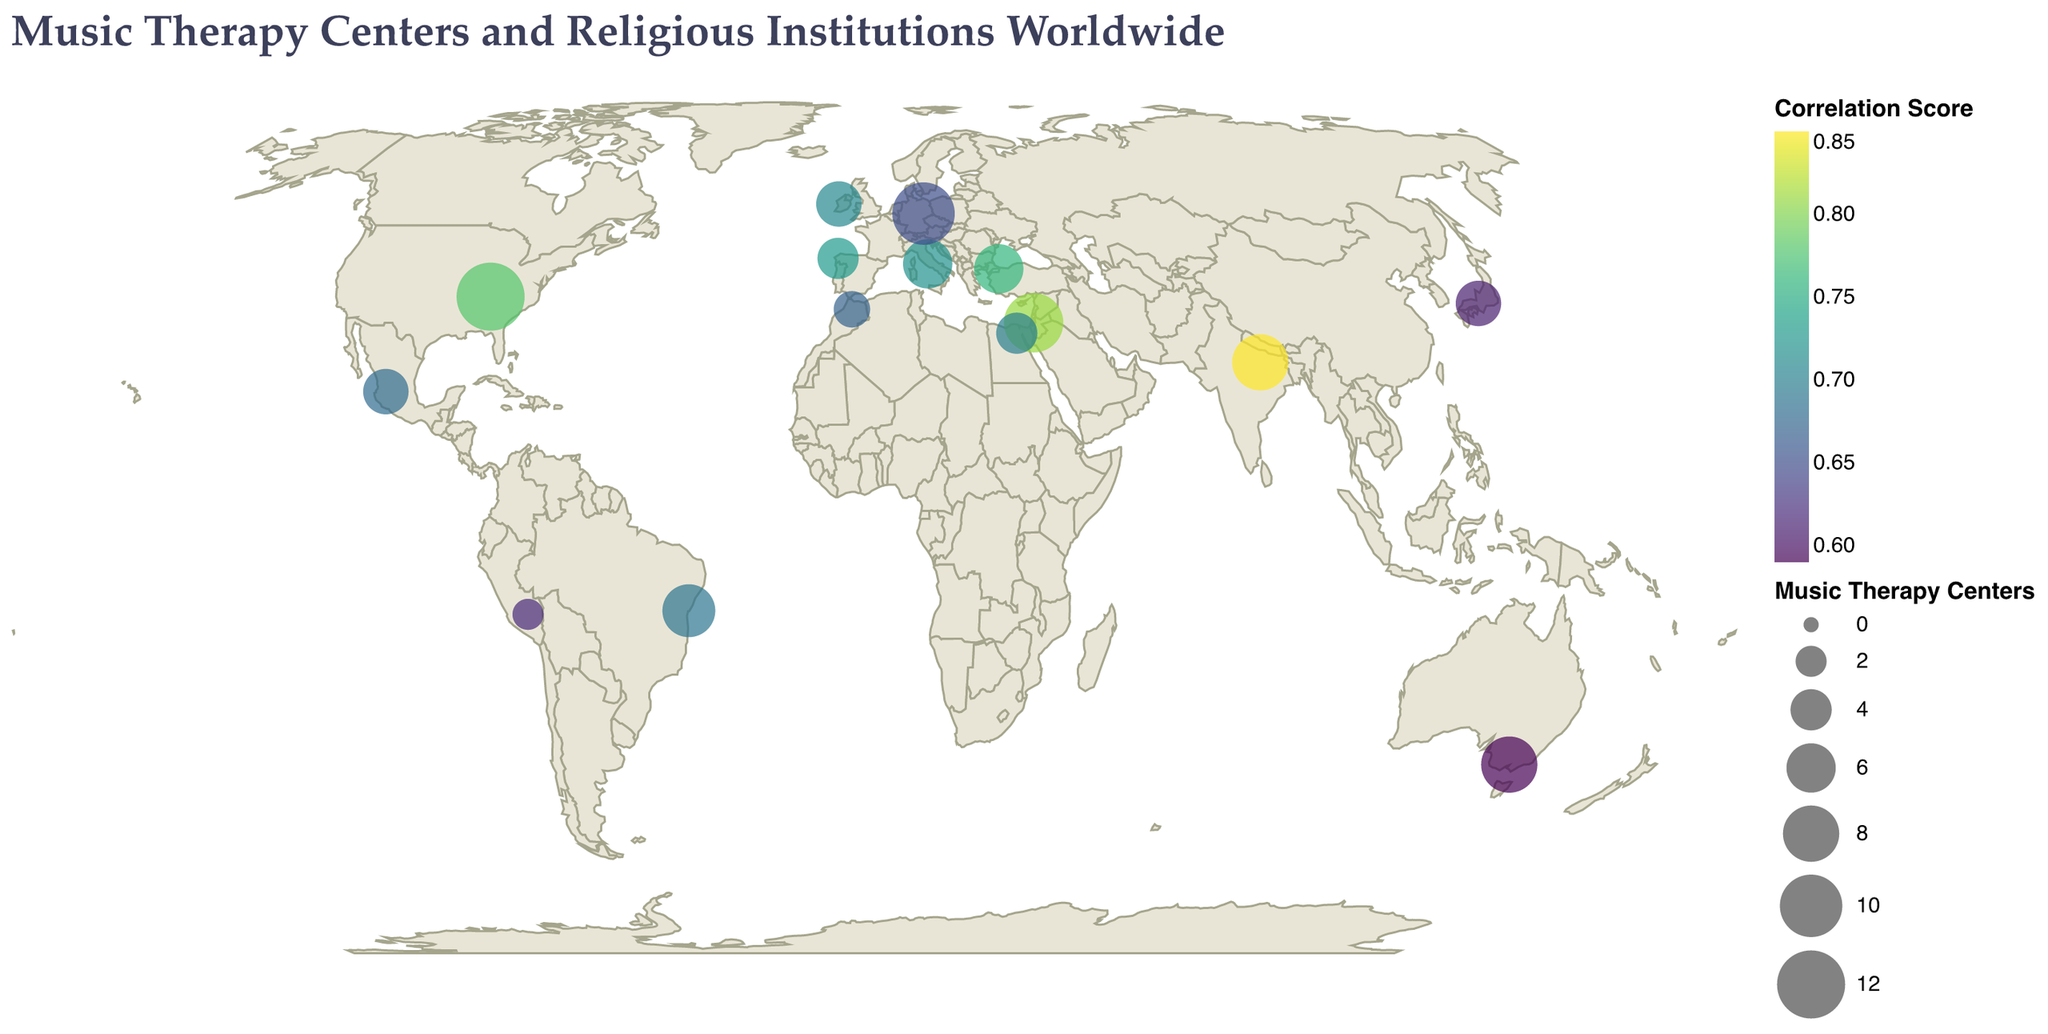How many Music Therapy Centers are there in Nashville? The plot shows the number of Music Therapy Centers indicated by the size of the circle. Nashville has a labeled count of 12 Music Therapy Centers.
Answer: 12 Which city has the highest number of Religious Institutions? The plot colorizes the cities based on the number of Religious Institutions. Jerusalem has the highest number of Religious Institutions, with 128 as indicated in the data table.
Answer: Jerusalem What is the Correlation Score between Music Therapy Centers and Religious Institutions in Galway? The color legend indicates the Correlation Score, and the data table shows that Galway has a Correlation Score of 0.71.
Answer: 0.71 Compare the number of Music Therapy Centers in Rome and Kyoto. Which city has more? According to the data table, Rome has 6 Music Therapy Centers while Kyoto has 5. Thus, Rome has more Music Therapy Centers.
Answer: Rome What are the colors representing in the circles on the plot? The color represents the Correlation Score between Music Therapy Centers and Religious Institutions, with a scale legend showing the range of values.
Answer: Correlation Score Which city has the lowest Correlation Score and what is that value? Melbourne has the lowest Correlation Score, which is 0.59 according to the data table.
Answer: Melbourne, 0.59 What is the total number of Music Therapy Centers in the cities provided? Sum the number of Music Therapy Centers: 12 (Nashville) + 8 (Varanasi) + 6 (Rome) + 5 (Kyoto) + 7 (Salvador) + 9 (Jerusalem) + 10 (Leipzig) + 4 (Santiago de Compostela) + 3 (Fez) + 8 (Melbourne) + 5 (Galway) + 6 (Istanbul) + 2 (Cusco) + 4 (Cairo) + 5 (Guadalajara) = 94.
Answer: 94 Which cities have more than 100 Religious Institutions? Rome (112), Jerusalem (128), and Istanbul (103) have more than 100 Religious Institutions as shown in the data table.
Answer: Rome, Jerusalem, Istanbul Is there a relationship between the number of Religious Institutions and Music Therapy Centers in the plot? The plot shows a positive correlation between the number of Religious Institutions and Music Therapy Centers in most cities, as indicated by the correlation scores. For example, Varanasi has both high numbers and a high correlation score of 0.85.
Answer: Yes What is the average Correlation Score across all cities? Add the Correlation Scores from all cities and divide by the number of cities: (0.78 + 0.85 + 0.72 + 0.61 + 0.69 + 0.81 + 0.65 + 0.73 + 0.67 + 0.59 + 0.71 + 0.76 + 0.62 + 0.70 + 0.68) / 15 = 10.77 / 15 ≈ 0.72.
Answer: 0.72 